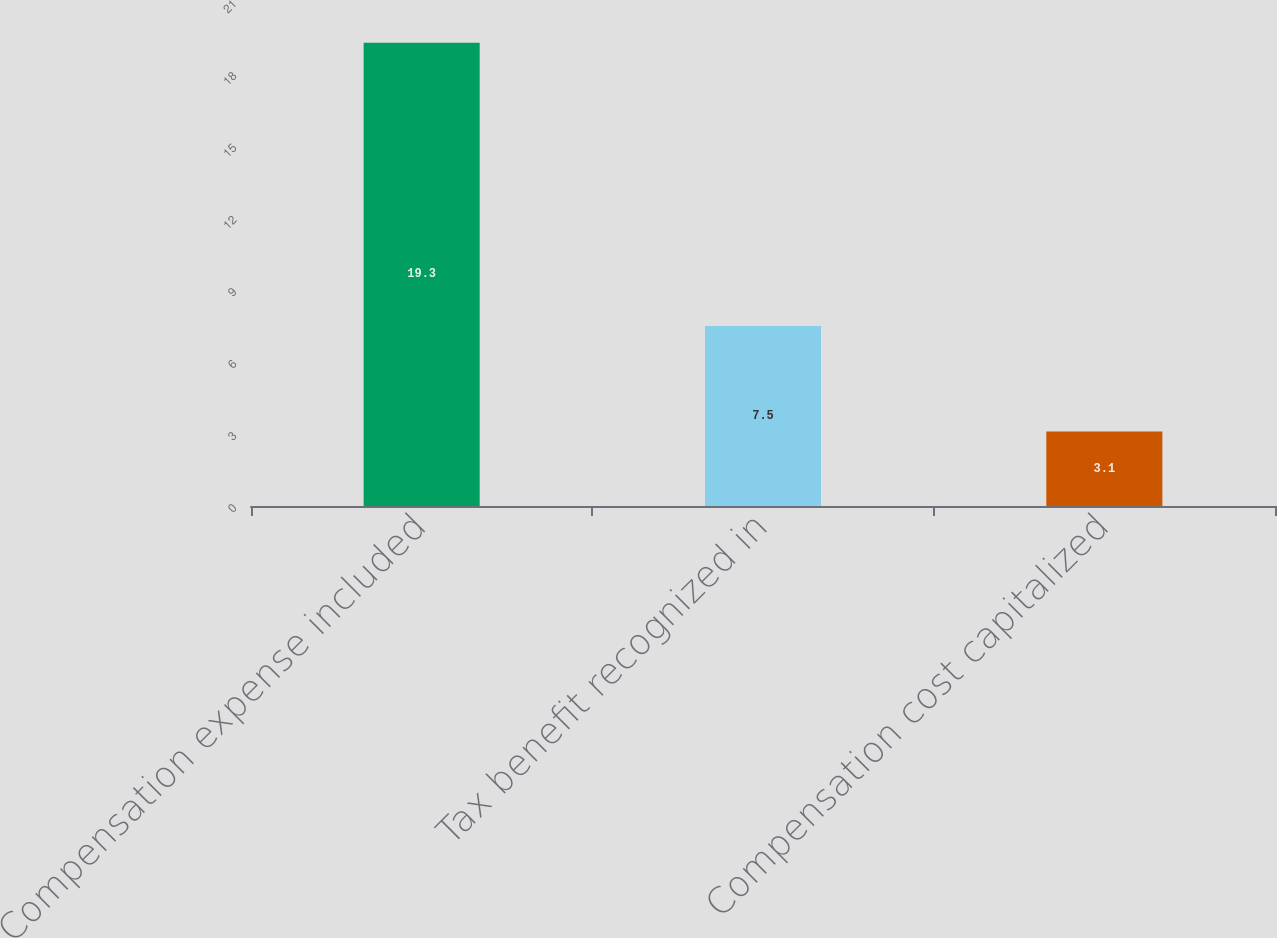Convert chart to OTSL. <chart><loc_0><loc_0><loc_500><loc_500><bar_chart><fcel>Compensation expense included<fcel>Tax benefit recognized in<fcel>Compensation cost capitalized<nl><fcel>19.3<fcel>7.5<fcel>3.1<nl></chart> 